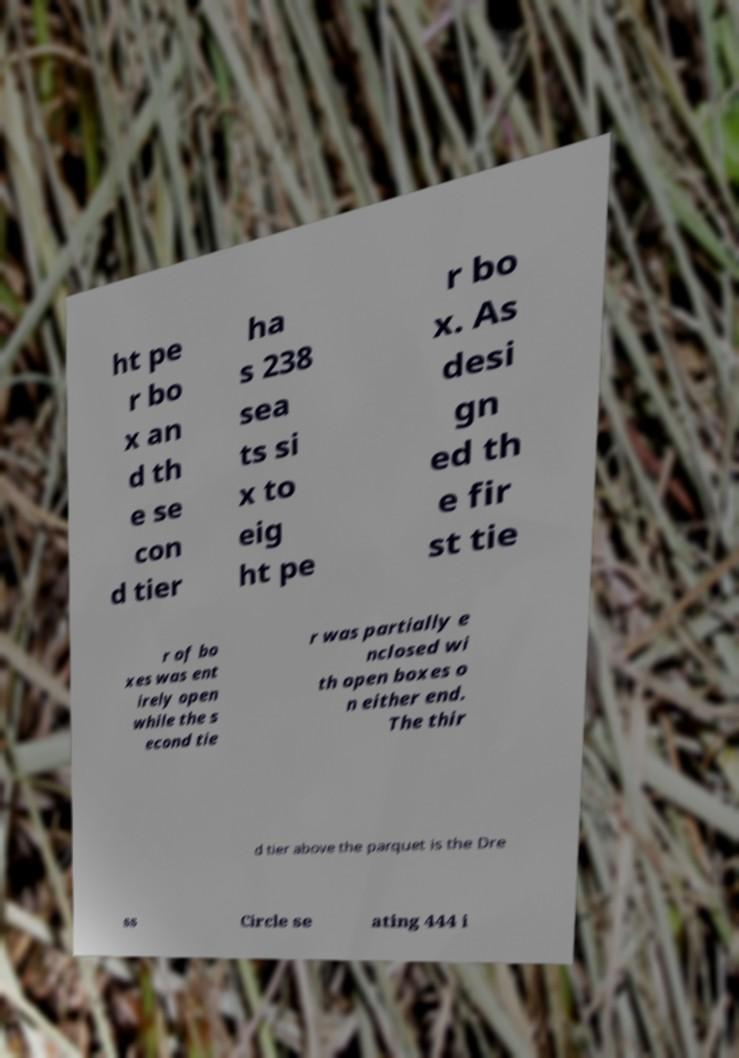Could you extract and type out the text from this image? ht pe r bo x an d th e se con d tier ha s 238 sea ts si x to eig ht pe r bo x. As desi gn ed th e fir st tie r of bo xes was ent irely open while the s econd tie r was partially e nclosed wi th open boxes o n either end. The thir d tier above the parquet is the Dre ss Circle se ating 444 i 